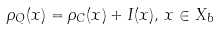Convert formula to latex. <formula><loc_0><loc_0><loc_500><loc_500>\rho _ { Q } ( x ) = \rho _ { C } ( x ) + I ( x ) , \, x \in X _ { b }</formula> 